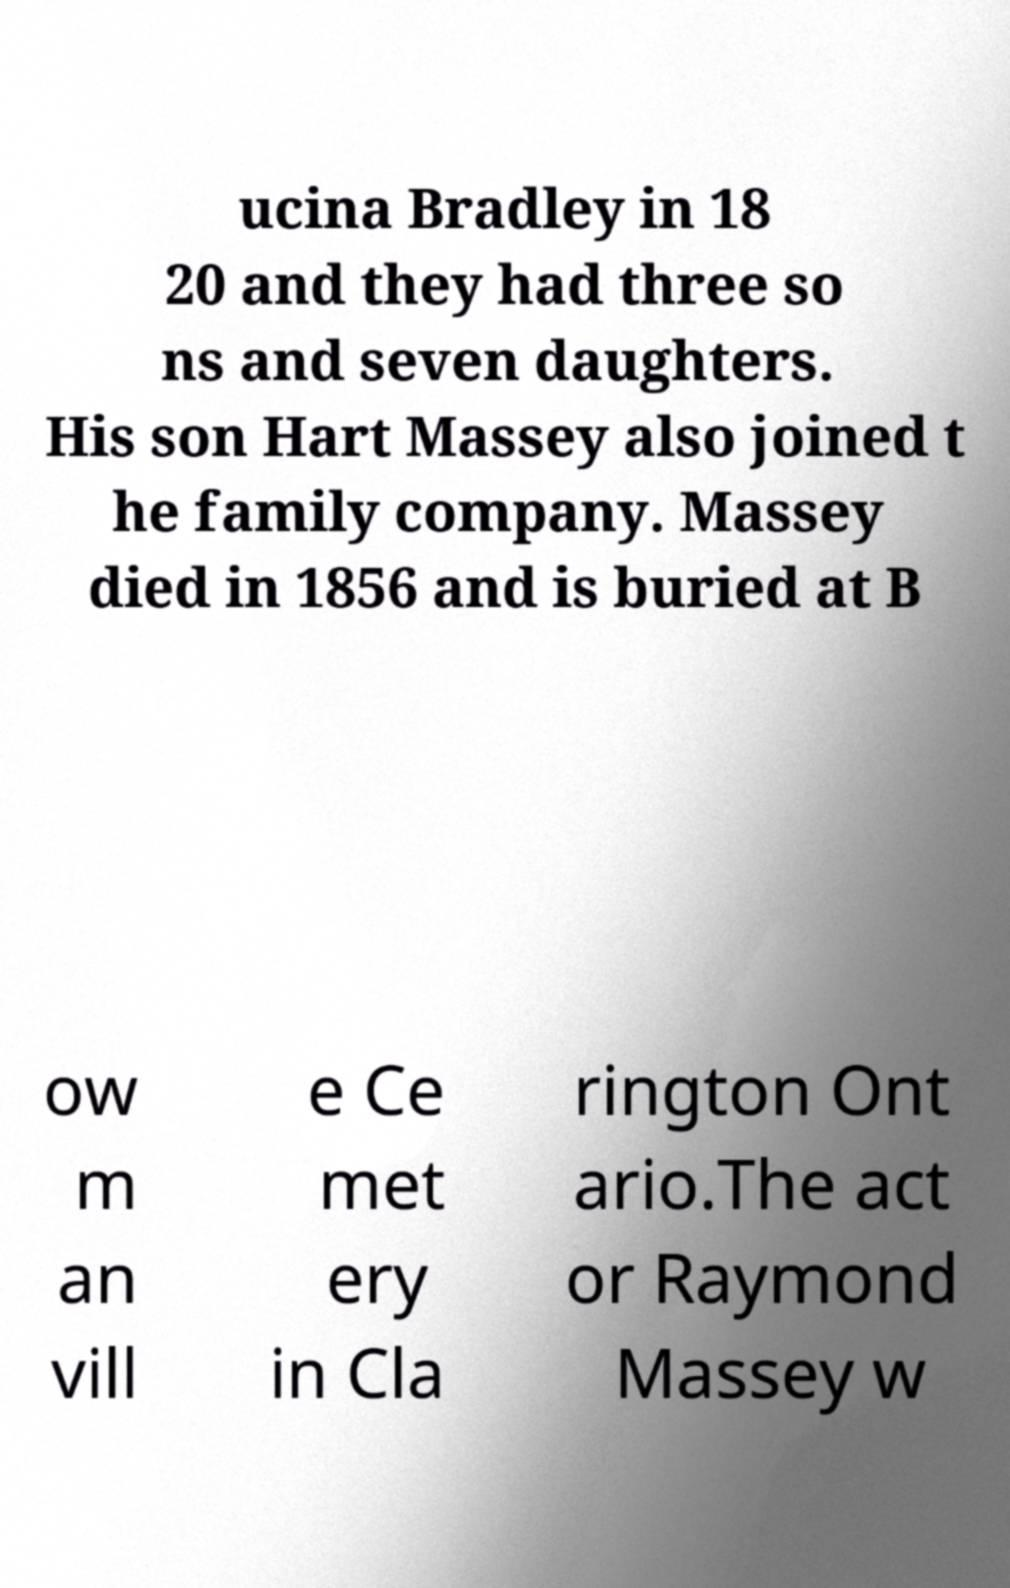Please read and relay the text visible in this image. What does it say? ucina Bradley in 18 20 and they had three so ns and seven daughters. His son Hart Massey also joined t he family company. Massey died in 1856 and is buried at B ow m an vill e Ce met ery in Cla rington Ont ario.The act or Raymond Massey w 